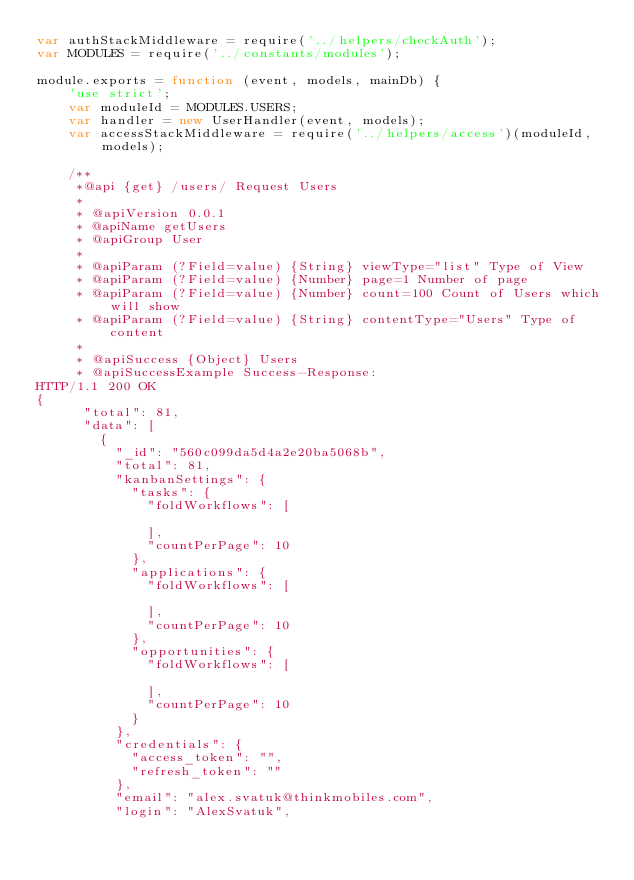Convert code to text. <code><loc_0><loc_0><loc_500><loc_500><_JavaScript_>var authStackMiddleware = require('../helpers/checkAuth');
var MODULES = require('../constants/modules');

module.exports = function (event, models, mainDb) {
    'use strict';
    var moduleId = MODULES.USERS;
    var handler = new UserHandler(event, models);
    var accessStackMiddleware = require('../helpers/access')(moduleId, models);

    /**
     *@api {get} /users/ Request Users
     *
     * @apiVersion 0.0.1
     * @apiName getUsers
     * @apiGroup User
     *
     * @apiParam (?Field=value) {String} viewType="list" Type of View
     * @apiParam (?Field=value) {Number} page=1 Number of page
     * @apiParam (?Field=value) {Number} count=100 Count of Users which will show
     * @apiParam (?Field=value) {String} contentType="Users" Type of content
     *
     * @apiSuccess {Object} Users
     * @apiSuccessExample Success-Response:
HTTP/1.1 200 OK
{
      "total": 81,
      "data": [
        {
          "_id": "560c099da5d4a2e20ba5068b",
          "total": 81,
          "kanbanSettings": {
            "tasks": {
              "foldWorkflows": [

              ],
              "countPerPage": 10
            },
            "applications": {
              "foldWorkflows": [

              ],
              "countPerPage": 10
            },
            "opportunities": {
              "foldWorkflows": [

              ],
              "countPerPage": 10
            }
          },
          "credentials": {
            "access_token": "",
            "refresh_token": ""
          },
          "email": "alex.svatuk@thinkmobiles.com",
          "login": "AlexSvatuk",</code> 